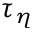Convert formula to latex. <formula><loc_0><loc_0><loc_500><loc_500>\tau _ { \eta }</formula> 